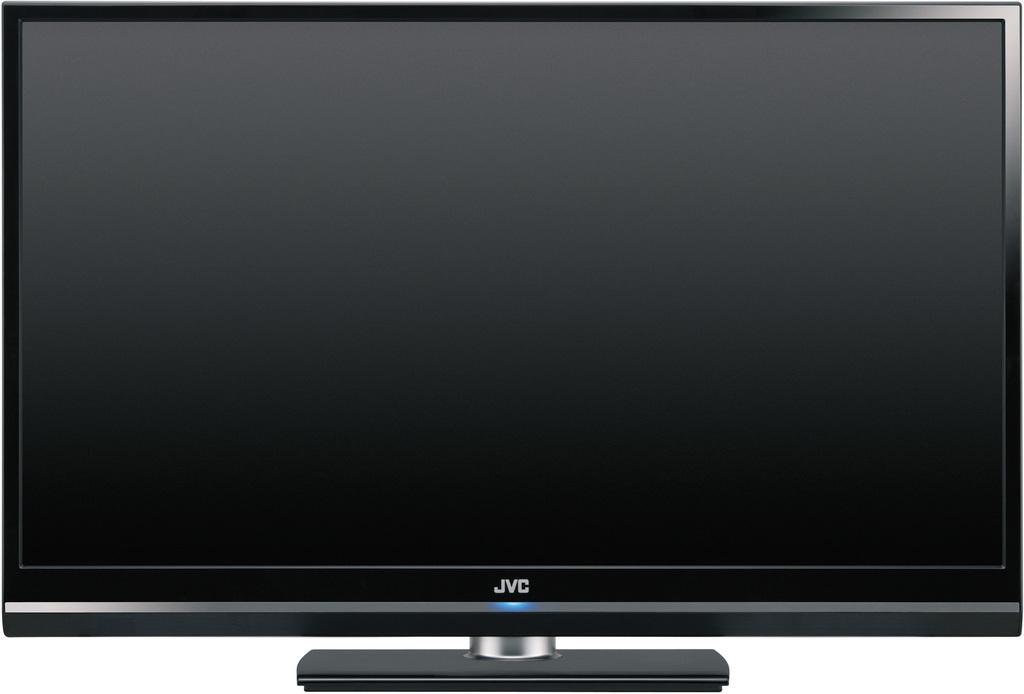What brand of tv is this?
Your answer should be compact. Jvc. 